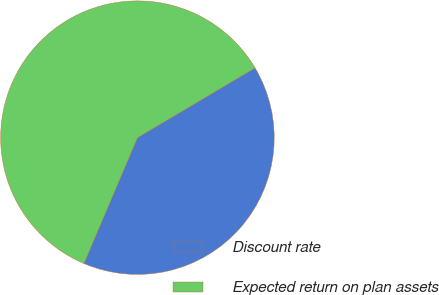<chart> <loc_0><loc_0><loc_500><loc_500><pie_chart><fcel>Discount rate<fcel>Expected return on plan assets<nl><fcel>39.92%<fcel>60.08%<nl></chart> 